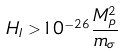Convert formula to latex. <formula><loc_0><loc_0><loc_500><loc_500>H _ { I } > 1 0 ^ { - 2 6 } \frac { M _ { p } ^ { 2 } } { m _ { \sigma } }</formula> 